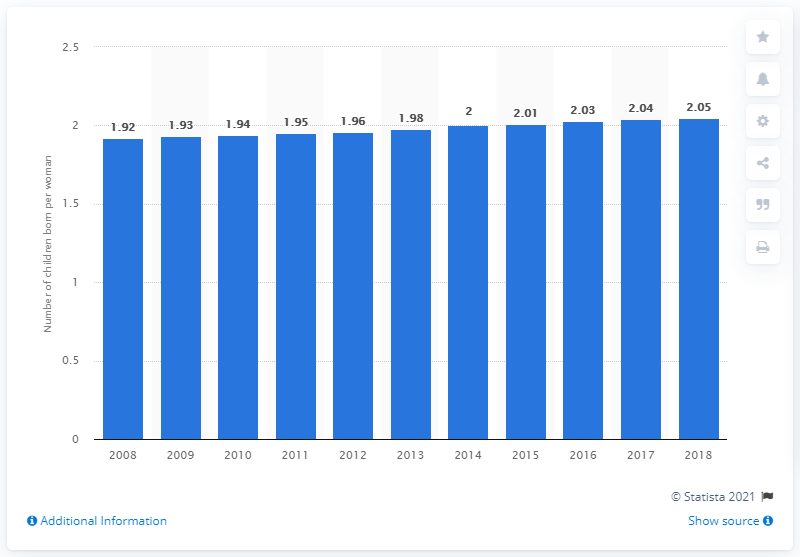List a handful of essential elements in this visual. In 2018, the fertility rate in Vietnam was 2.05. 